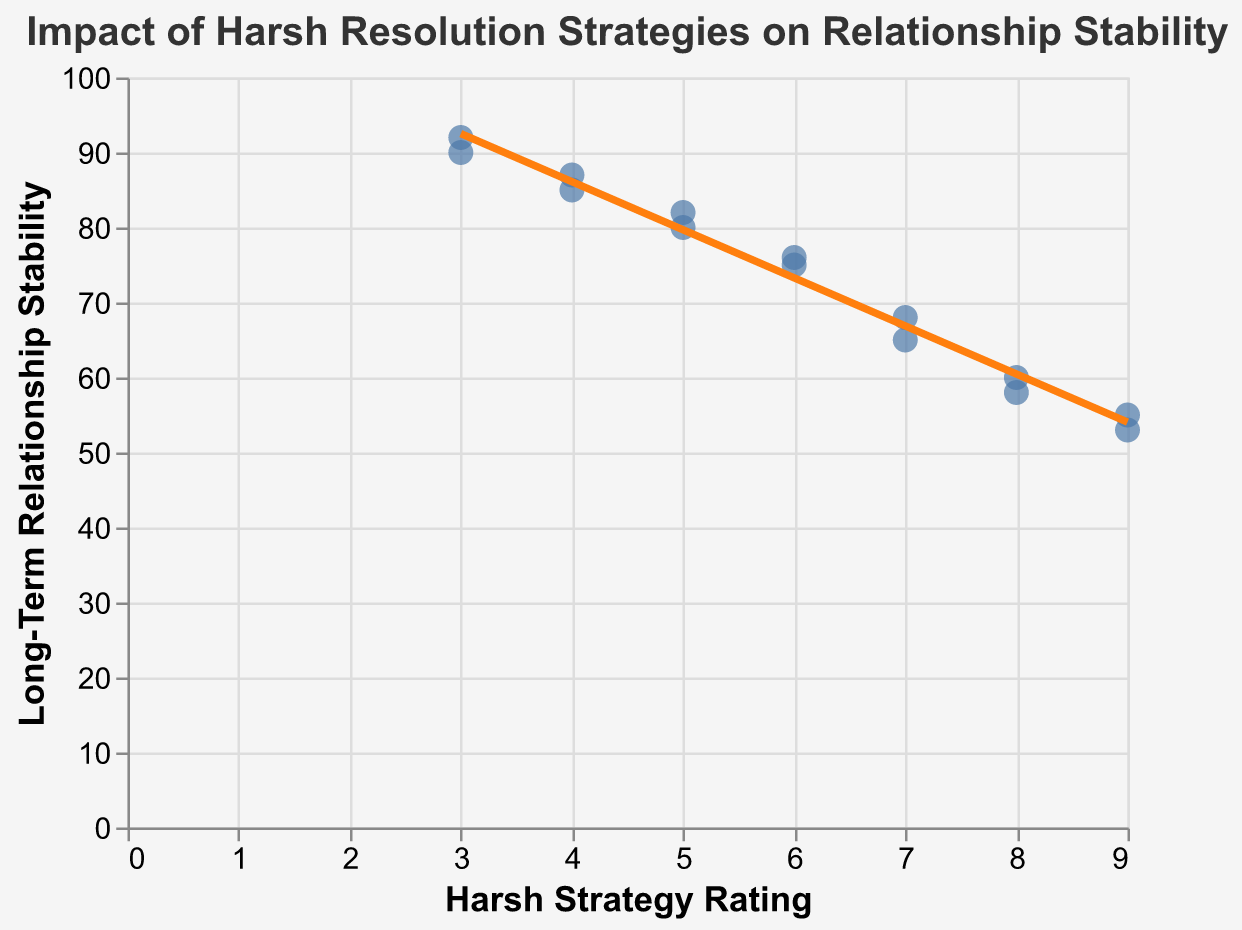What is the title of the plot? The title is located at the top of the figure, and it directly states the focus of the plot.
Answer: Impact of Harsh Resolution Strategies on Relationship Stability How many data points are shown in the scatter plot? The number of data points corresponds to the number of specialists listed in the data section.
Answer: 14 What is the Harsh Strategy Rating of the specialist with the highest Long-Term Relationship Stability? From examining the tooltip of each data point, the highest stability is found at a Long-Term Relationship Stability value of 92, linked to the specialist with a Harsh Strategy Rating of 3.
Answer: 3 What is the general trend shown by the trend line in the plot? The trend line visually indicates the average relationship between the Harsh Strategy Ratings and Long-Term Relationship Stability. It displays a downward slope, suggesting that as the Harsh Strategy Rating increases, the Long-Term Relationship Stability tends to decrease.
Answer: Negative correlation Which specialist has a Harsh Strategy Rating of 9 and what is their corresponding Long-Term Relationship Stability? By checking the points specifically with a Harsh Strategy Rating of 9 in the plot and using the tooltip, the specialist can be identified.
Answer: Andrew Scott with Long-Term Relationship Stability of 53 Which two specialists have the closest Long-Term Relationship Stability values? Comparing the stability values from the data, Michael Brown (85) and David Allen (87) are the closest in value, having just a 2 point difference.
Answer: Michael Brown and David Allen What is the average Long-Term Relationship Stability for specialists with a Harsh Strategy Rating greater than 6? Identify the specialists with a Harsh Strategy Rating greater than 6 and then calculate the average of their Long-Term Relationship Stability values. Specialists: Joan Smith (60), Alice Johnson (55), James Walker (58), Andrew Scott (53). Calculating the average: (60 + 55 + 58 + 53) / 4 = 226 / 4.
Answer: 56.5 Do any specialists have both a Harsh Strategy Rating and Long-Term Relationship Stability above 80? Review each data point to see if any specialist meets both criteria. None of the specialists have values above 80 for both metrics.
Answer: No Which specialist demonstrates an outlier in terms of having a high Harsh Strategy Rating but maintaining a relatively high Long-Term Relationship Stability? By looking at the trend line, it's apparent that as Harsh Strategy Ratings increase, Long-Term Relationship Stability typically decreases. Michael Brown, with a Harsh Strategy Rating of 4 and a Long-Term Relationship Stability of 85, stands out.
Answer: Michael Brown Which specialist shows the lowest Long-Term Relationship Stability, and what is their Harsh Strategy Rating? Using the plot's tooltips, identify the data point with the lowest stability value. Andrew Scott with a Long-Term Relationship Stability of 53 and a Harsh Strategy Rating of 9.
Answer: Andrew Scott with Harsh Strategy Rating of 9 